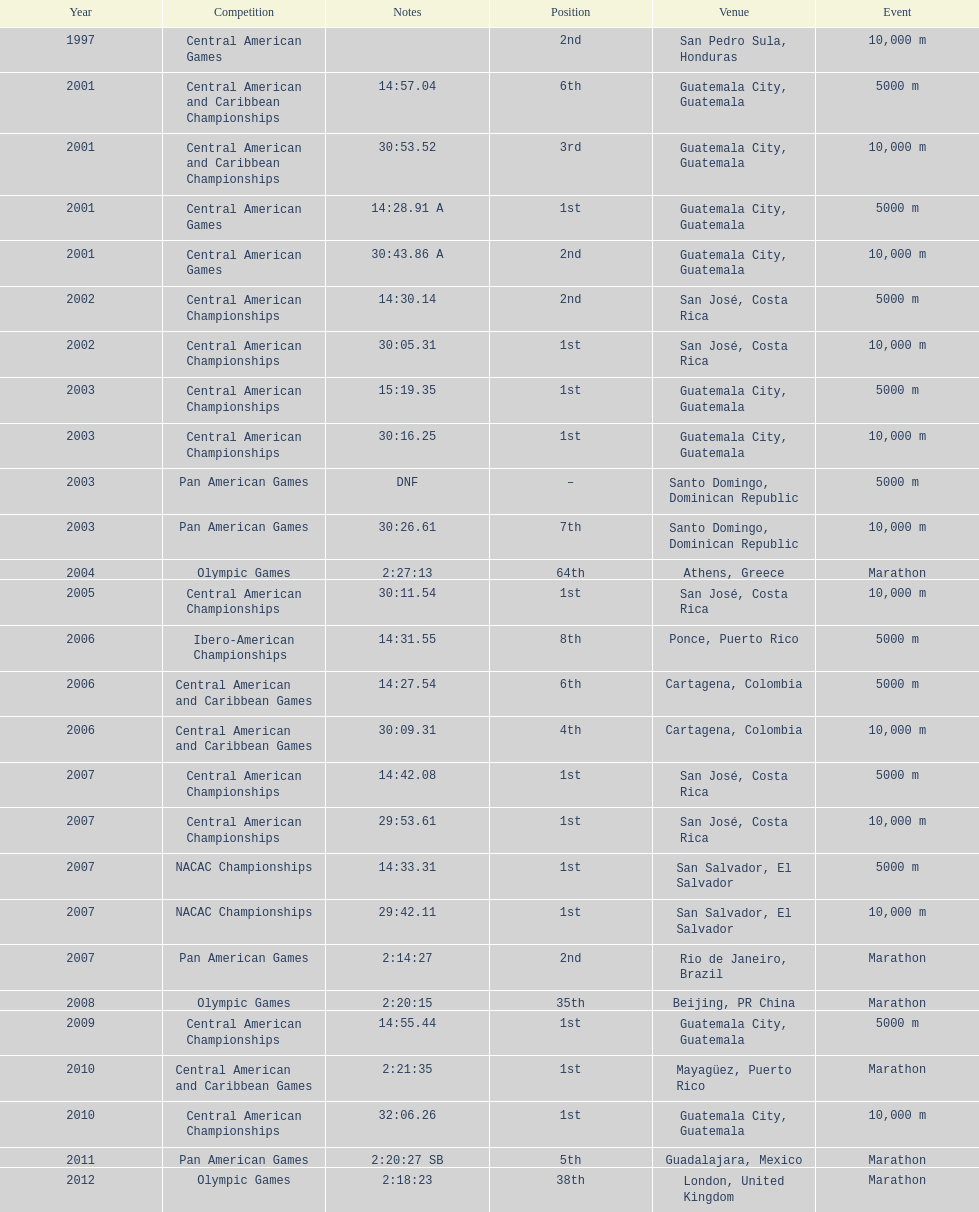Tell me the number of times they competed in guatamala. 5. 